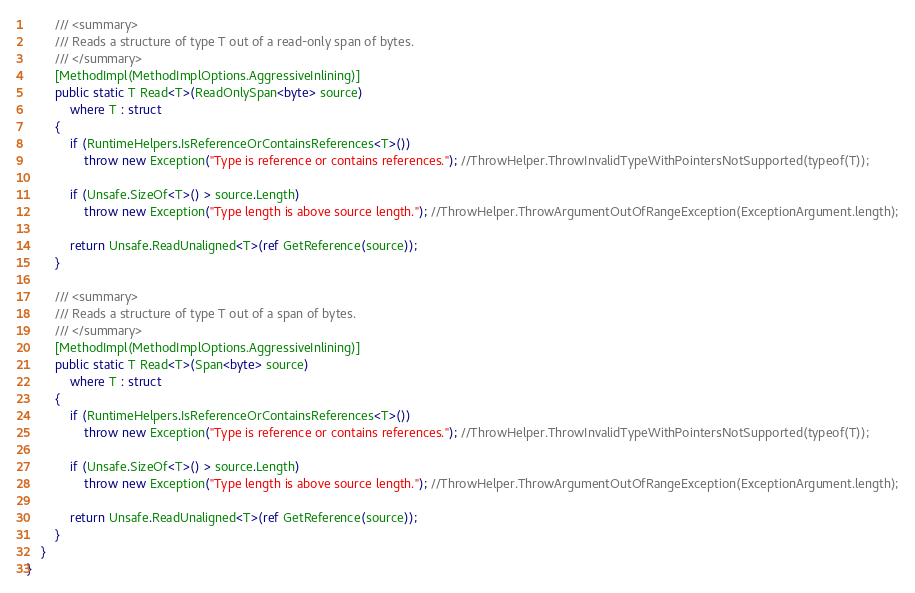<code> <loc_0><loc_0><loc_500><loc_500><_C#_>
		/// <summary>
		/// Reads a structure of type T out of a read-only span of bytes.
		/// </summary>
		[MethodImpl(MethodImplOptions.AggressiveInlining)]
		public static T Read<T>(ReadOnlySpan<byte> source)
			where T : struct
		{
			if (RuntimeHelpers.IsReferenceOrContainsReferences<T>())
				throw new Exception("Type is reference or contains references."); //ThrowHelper.ThrowInvalidTypeWithPointersNotSupported(typeof(T));

			if (Unsafe.SizeOf<T>() > source.Length)
				throw new Exception("Type length is above source length."); //ThrowHelper.ThrowArgumentOutOfRangeException(ExceptionArgument.length);

			return Unsafe.ReadUnaligned<T>(ref GetReference(source));
		}

		/// <summary>
		/// Reads a structure of type T out of a span of bytes.
		/// </summary>
		[MethodImpl(MethodImplOptions.AggressiveInlining)]
		public static T Read<T>(Span<byte> source)
			where T : struct
		{
			if (RuntimeHelpers.IsReferenceOrContainsReferences<T>())
				throw new Exception("Type is reference or contains references."); //ThrowHelper.ThrowInvalidTypeWithPointersNotSupported(typeof(T));

			if (Unsafe.SizeOf<T>() > source.Length)
				throw new Exception("Type length is above source length."); //ThrowHelper.ThrowArgumentOutOfRangeException(ExceptionArgument.length);

			return Unsafe.ReadUnaligned<T>(ref GetReference(source));
		}
	}
}</code> 